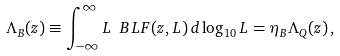<formula> <loc_0><loc_0><loc_500><loc_500>\Lambda _ { B } ( z ) \equiv \int _ { - \infty } ^ { \infty } L \ B L F ( z , L ) \, d \log _ { 1 0 } L = \eta _ { B } \Lambda _ { Q } ( z ) \, ,</formula> 